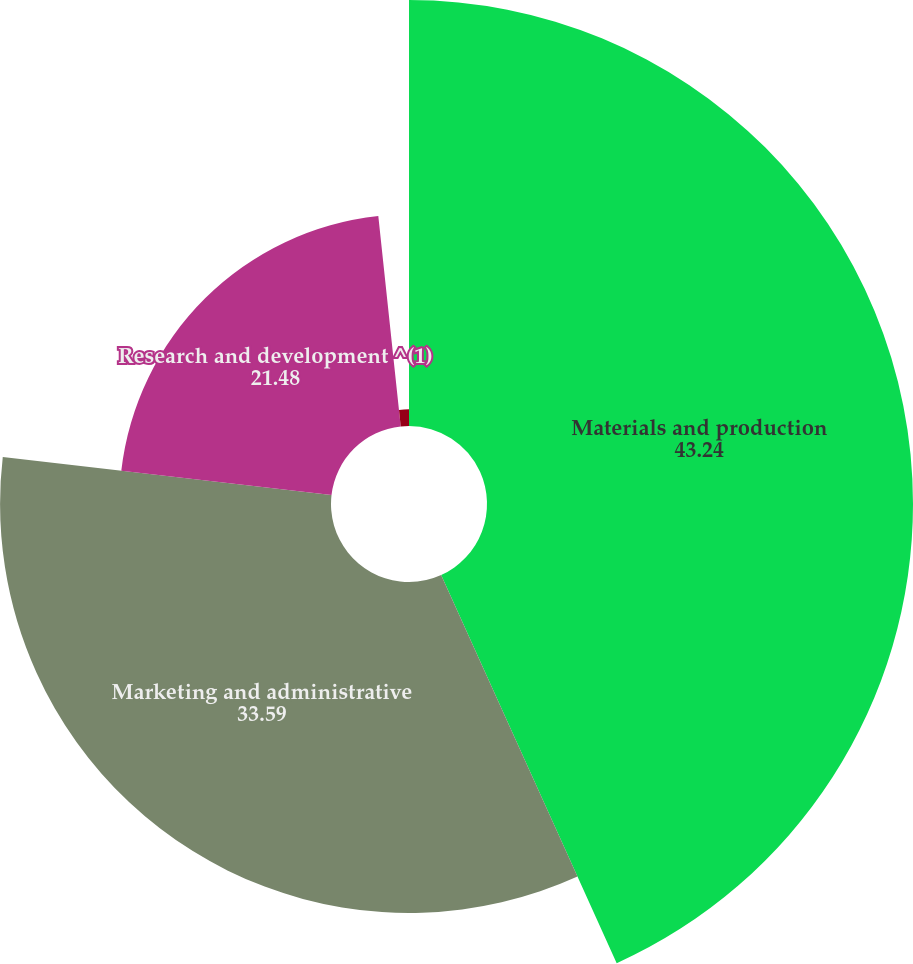<chart> <loc_0><loc_0><loc_500><loc_500><pie_chart><fcel>Materials and production<fcel>Marketing and administrative<fcel>Research and development ^(1)<fcel>Equity income from affiliates<nl><fcel>43.24%<fcel>33.59%<fcel>21.48%<fcel>1.69%<nl></chart> 